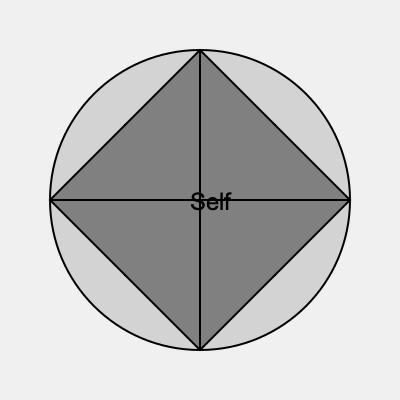In this mixed-media installation addressing identity and representation, what does the overlapping of geometric shapes and the centrally placed text suggest about the artist's exploration of self-concept? 1. Spatial arrangement:
   - The installation consists of overlapping geometric shapes: a circle, square, and diamond.
   - These shapes are centered around the text "Self" in the middle.

2. Symbolism of shapes:
   - Circle: Often represents wholeness, unity, or the cyclical nature of life.
   - Square: Can symbolize stability, foundation, or the physical world.
   - Diamond/Rhombus: May represent value, transformation, or a different perspective.

3. Overlapping shapes:
   - The intersection of these shapes creates various segments and layers.
   - This suggests the multifaceted nature of identity and the complexity of self-representation.

4. Central text "Self":
   - Placement at the center implies that self-concept is at the core of the installation.
   - The text is surrounded by the overlapping shapes, indicating that the self is influenced by and composed of various elements.

5. Color gradation:
   - The shapes progress from light to dark, moving inward.
   - This could represent the journey of self-discovery or the layers of identity from surface to core.

6. Intersecting lines:
   - The horizontal and vertical lines divide the installation into quadrants.
   - This may symbolize the different aspects or dimensions of identity (e.g., personal, social, cultural, professional).

7. Overall composition:
   - The symmetrical arrangement suggests balance and introspection.
   - The layered, intersecting elements imply that identity is not singular but a complex interplay of various factors.

Conclusion:
The installation suggests that the artist views self-concept as a multi-layered, complex construct influenced by various factors and perspectives. The overlapping shapes and central text imply that identity is not fixed but a dynamic interplay of different elements, all centered around a core sense of self.
Answer: Multi-layered, dynamic self-concept 